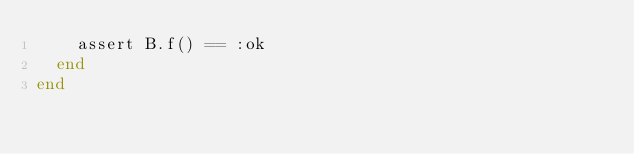Convert code to text. <code><loc_0><loc_0><loc_500><loc_500><_Elixir_>    assert B.f() == :ok
  end
end
</code> 